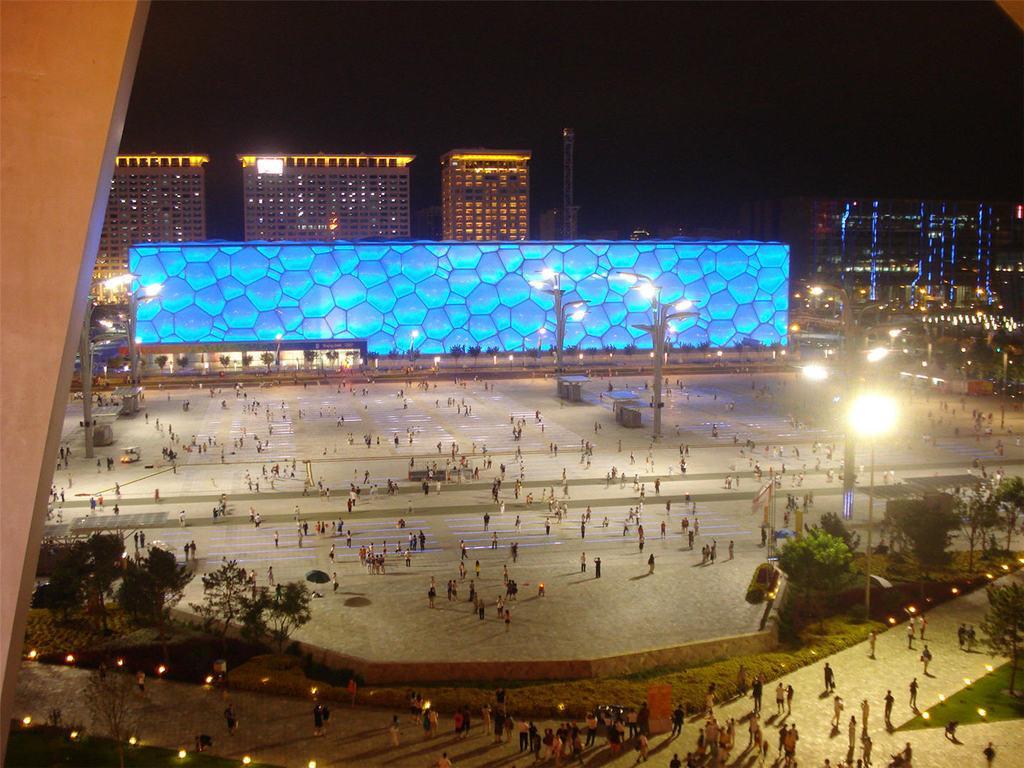Can you describe this image briefly? In this image we can see a few people, there are some poles, lights, tables, trees, buildings and a tower, also we can see the background is dark. 